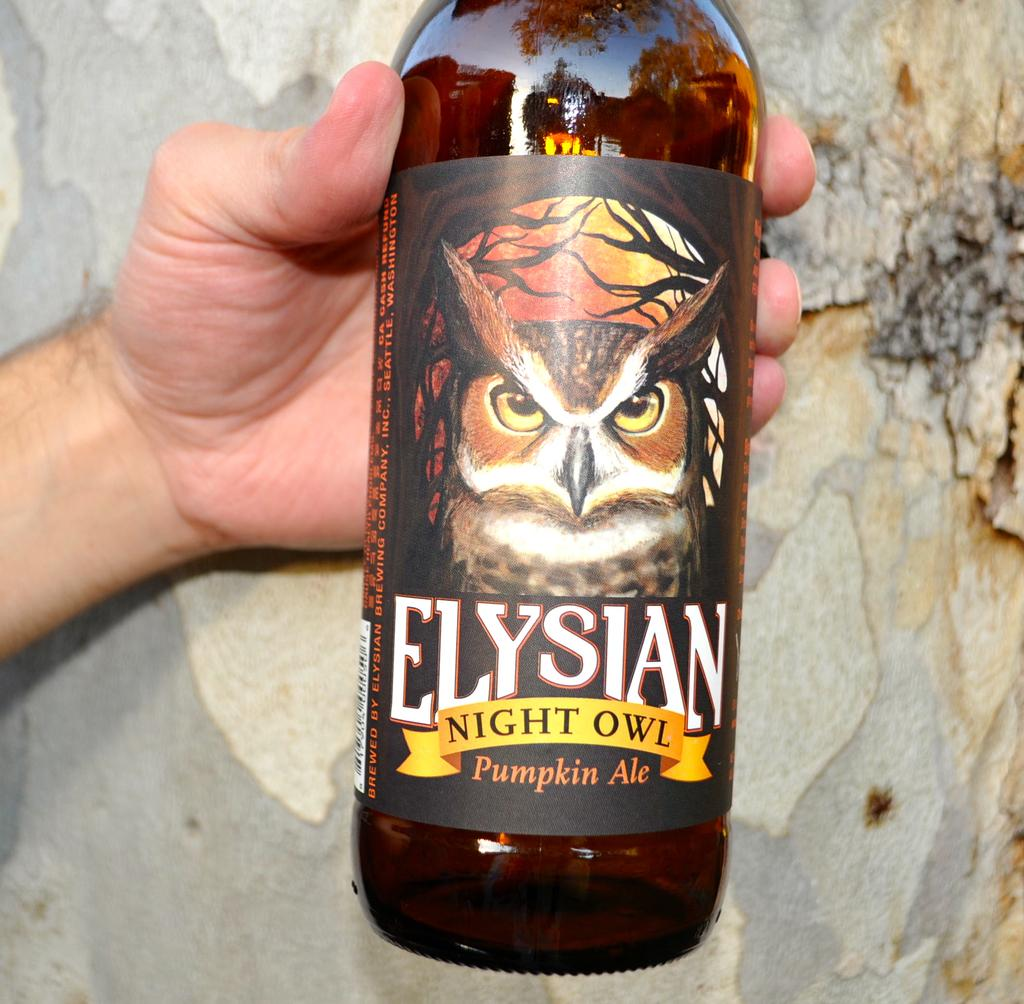<image>
Offer a succinct explanation of the picture presented. Person holding an Elysian Night Owl Pumpkin Ale beer bottle. 